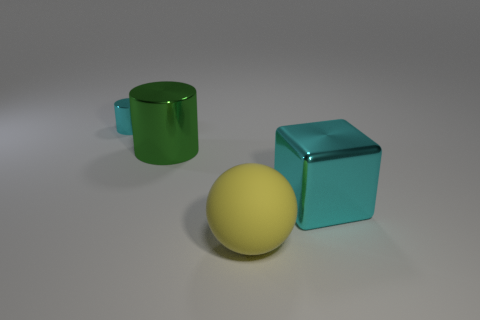How do the shadows formed by the objects contribute to the perception of the light source? The shadows are cast towards the lower right area of the image, suggesting that the light source is located on the upper left side. The length and softness of the shadows indicate that the light is not directly overhead and is somewhat diffused, possibly by a softbox or cloudy sky if this were an outdoor setting. 